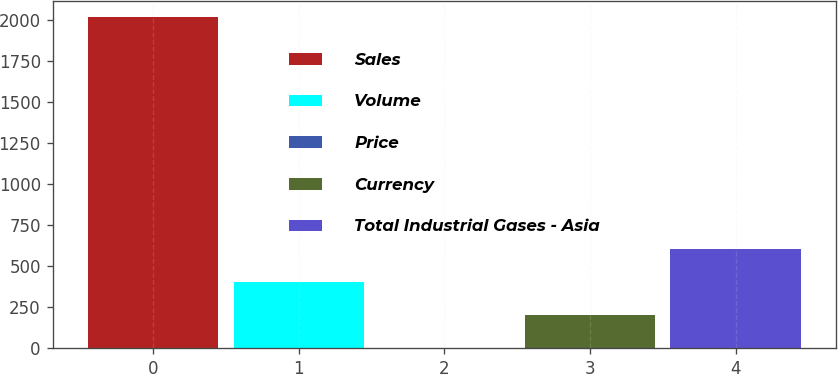<chart> <loc_0><loc_0><loc_500><loc_500><bar_chart><fcel>Sales<fcel>Volume<fcel>Price<fcel>Currency<fcel>Total Industrial Gases - Asia<nl><fcel>2017<fcel>404.2<fcel>1<fcel>202.6<fcel>605.8<nl></chart> 